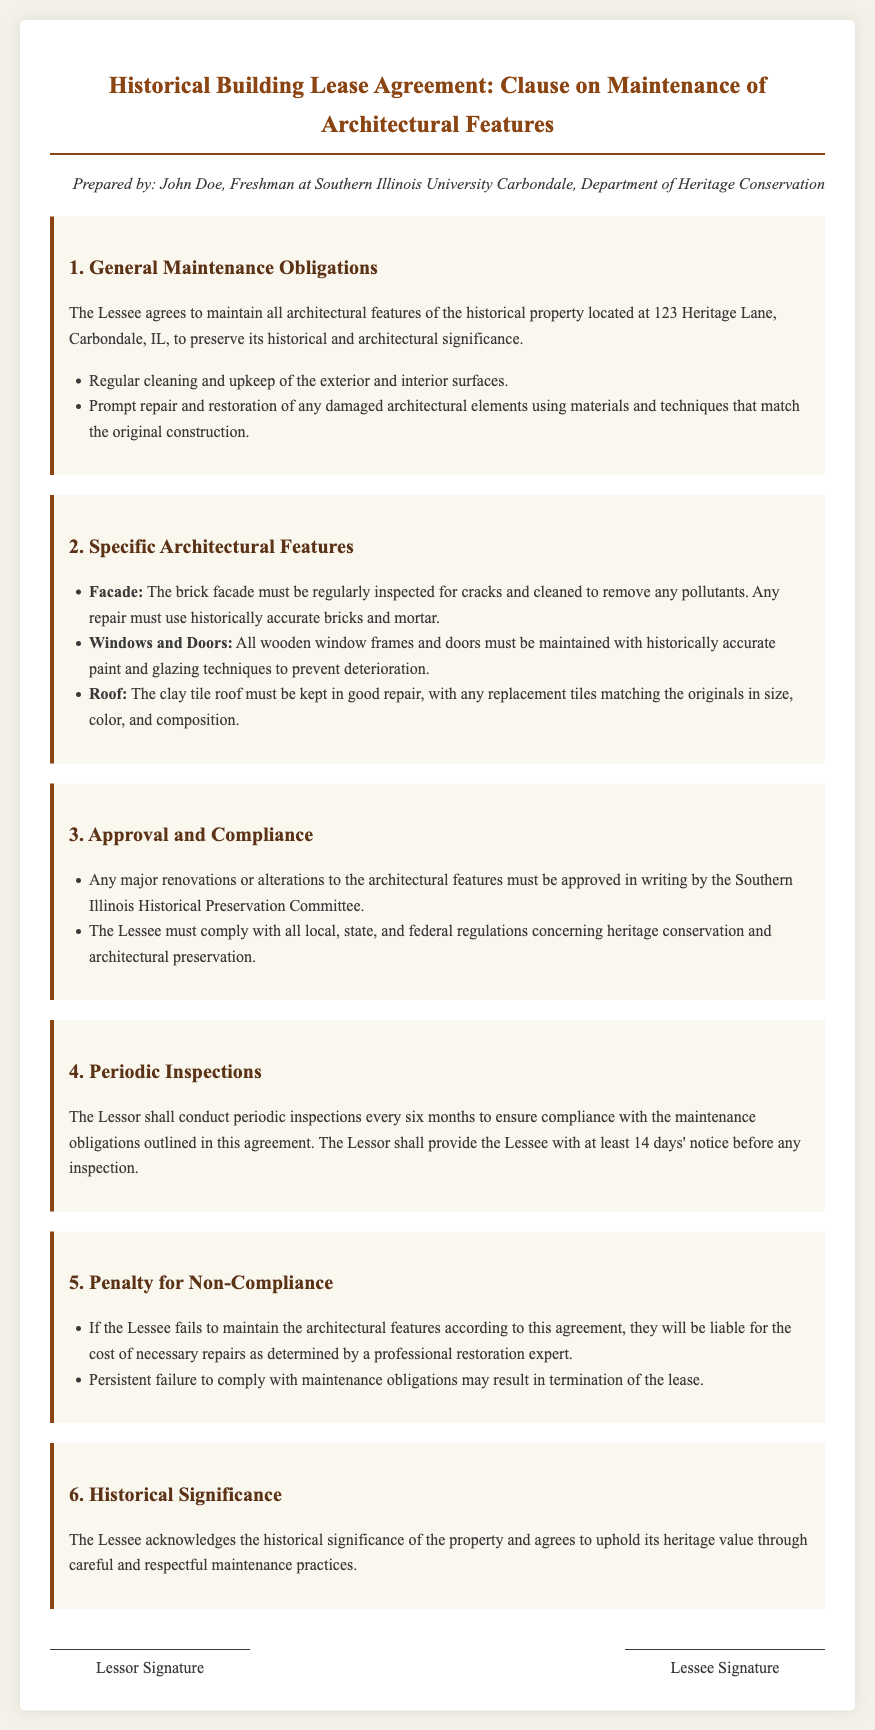What is the address of the historical property? The address of the historical property is specified in the general maintenance obligations section of the document.
Answer: 123 Heritage Lane, Carbondale, IL What must the Lessee maintain? The document states the obligations regarding maintenance in the first clause, which includes all architectural features.
Answer: All architectural features What is required for the brick facade? The specific architectural features section outlines the requirement for the brick facade regarding inspections and cleaning.
Answer: Regularly inspected for cracks and cleaned Who must approve major renovations? The approval requirement for any major renovations is mentioned in the compliance clause.
Answer: Southern Illinois Historical Preservation Committee What are the consequences of non-compliance? The consequences are detailed in the penalty clause, specifying liability issues and lease termination.
Answer: Cost of necessary repairs How often will inspections occur? This piece of information can be found in the periodic inspections clause, which details the frequency of checks.
Answer: Every six months What type of paint must be used on wooden window frames? The maintenance requirement for wooden window frames specifies the type of paint that must be maintained.
Answer: Historically accurate paint What is the Lessee's acknowledgment regarding the property? The document includes a clause that highlights the Lessee's recognition of the property's value.
Answer: Historical significance 